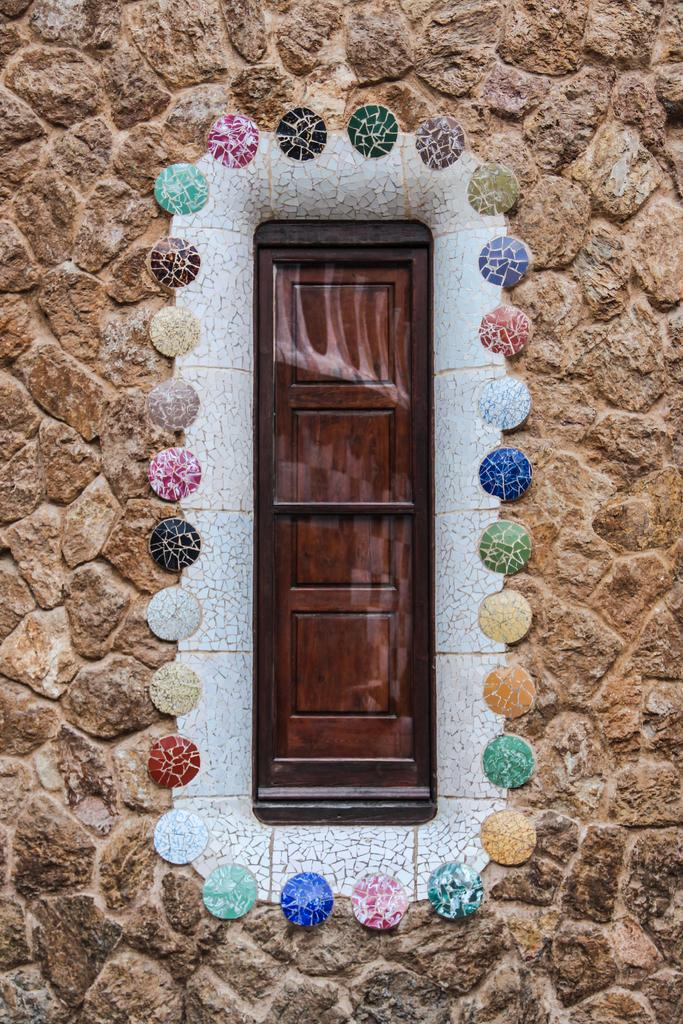What is the main architectural feature in the image? There is a door in the image. What decorative elements are present around the door? Colorful stones are around the door. What material is the wall made of? The wall is made of granite. What type of error can be seen in the image? There is no error present in the image; it is a clear depiction of a door, colorful stones, and a granite wall. Can you hear the drum in the image? There is no drum present in the image, so it cannot be heard. 